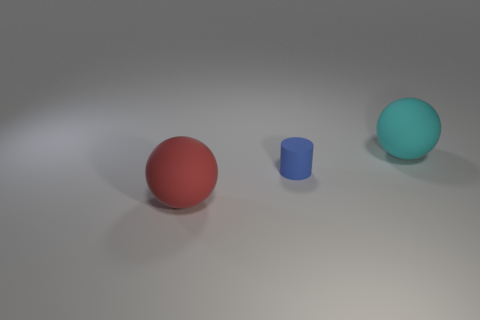Do the large object that is on the left side of the cyan object and the large sphere that is behind the red matte object have the same material?
Provide a short and direct response. Yes. What number of objects are matte objects that are behind the red ball or red matte things?
Ensure brevity in your answer.  3. How many things are either red metallic objects or balls in front of the cyan rubber thing?
Ensure brevity in your answer.  1. How many other objects have the same size as the red matte thing?
Ensure brevity in your answer.  1. Are there fewer large objects on the right side of the big red rubber sphere than small blue matte cylinders to the right of the tiny blue rubber thing?
Your answer should be very brief. No. How many metallic things are either large red spheres or large blue blocks?
Ensure brevity in your answer.  0. What is the shape of the large red thing?
Ensure brevity in your answer.  Sphere. What material is the red sphere that is the same size as the cyan matte ball?
Ensure brevity in your answer.  Rubber. What number of small things are red cylinders or blue things?
Give a very brief answer. 1. Are any large purple cubes visible?
Your answer should be compact. No. 